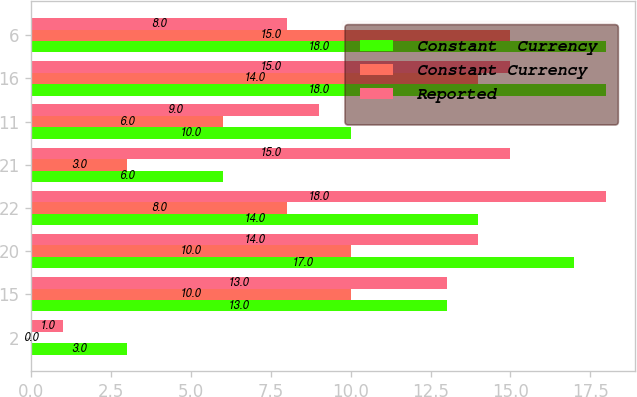Convert chart to OTSL. <chart><loc_0><loc_0><loc_500><loc_500><stacked_bar_chart><ecel><fcel>2<fcel>15<fcel>20<fcel>22<fcel>21<fcel>11<fcel>16<fcel>6<nl><fcel>Constant  Currency<fcel>3<fcel>13<fcel>17<fcel>14<fcel>6<fcel>10<fcel>18<fcel>18<nl><fcel>Constant Currency<fcel>0<fcel>10<fcel>10<fcel>8<fcel>3<fcel>6<fcel>14<fcel>15<nl><fcel>Reported<fcel>1<fcel>13<fcel>14<fcel>18<fcel>15<fcel>9<fcel>15<fcel>8<nl></chart> 